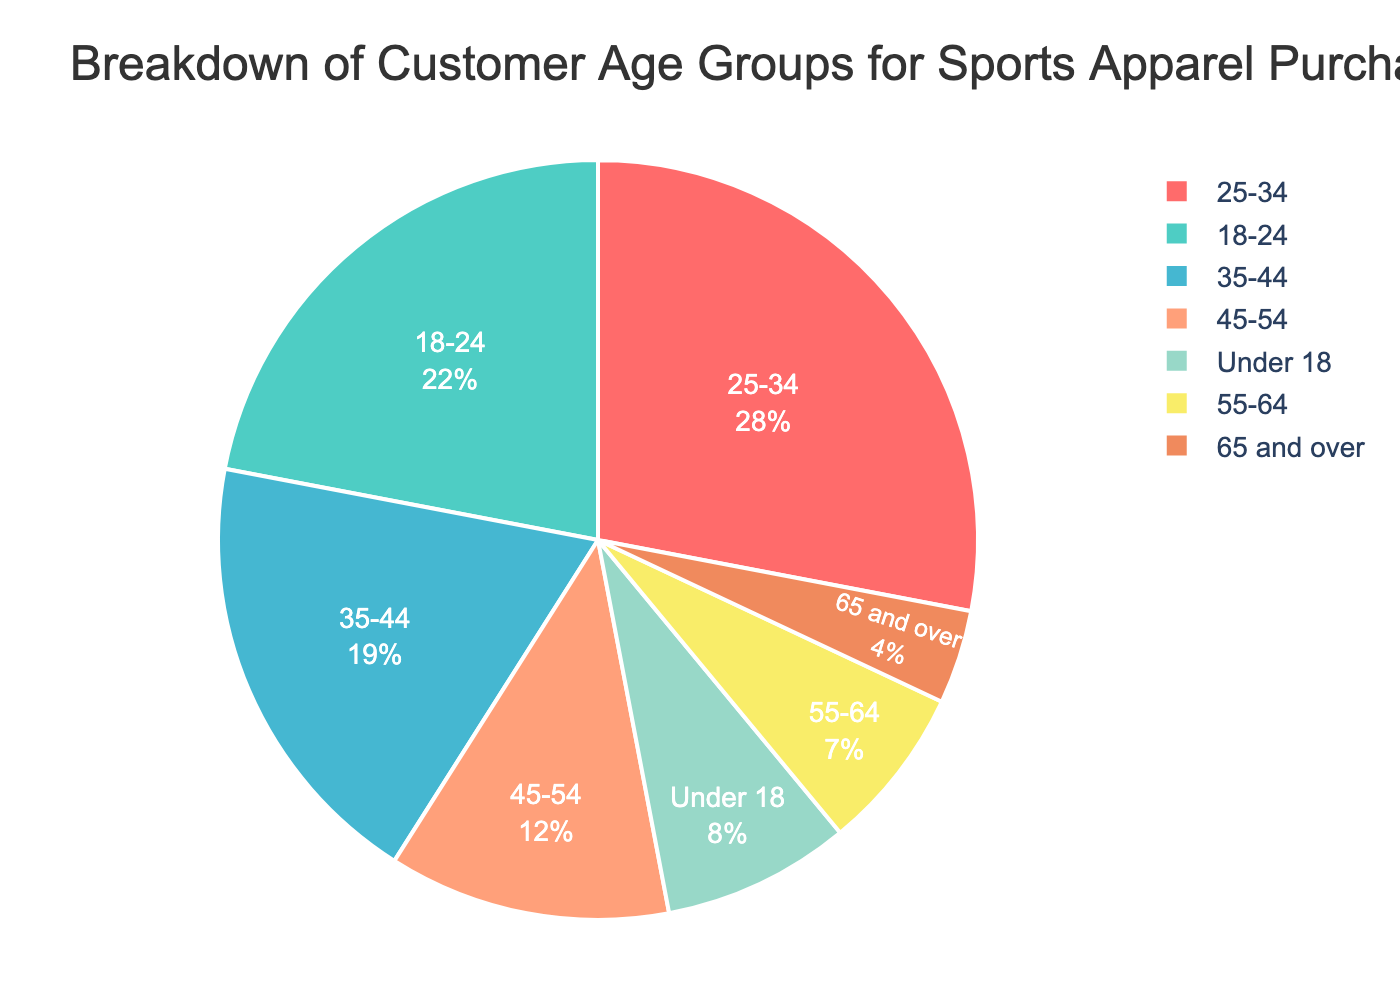What percentage of customers are aged 18-24? In the pie chart, look for the segment labeled "18-24" and read off the corresponding percentage.
Answer: 22% Which age group has the smallest percentage of customers? Look for the smallest segment in the pie chart and identify the label of that segment.
Answer: 65 and over What is the total percentage of customers aged 45 and above? Sum up the percentages of the age groups "45-54", "55-64", and "65 and over". 12% + 7% + 4% = 23%
Answer: 23% Which age group has a higher percentage of customers, Under 18 or 55-64? Compare the percentages associated with the age groups "Under 18" and "55-64". 8% (Under 18) vs 7% (55-64)
Answer: Under 18 What is the combined percentage of customers aged under 18 and over 65? Sum up the percentages of the age groups "Under 18" and "65 and over". 8% + 4% = 12%
Answer: 12% How does the percentage of customers aged 35-44 compare to those aged 35 and younger? Sum the percentages of the groups under 35: 8% (Under 18) + 22% (18-24) + 28% (25-34) = 58%. Compare this with the percentage for 35-44, which is 19%. 19% < 58%
Answer: 35-44 has a lower percentage What is the difference in the percentage of customers between the age groups 25-34 and 35-44? Subtract the percentage of the "35-44" age group from the "25-34" age group. 28% - 19% = 9%
Answer: 9% Which age group occupies the orange segment of the pie chart? Identify the color associated with the "orange" segment in the pie chart and find the corresponding age group label.
Answer: 35-44 What is the percentage of customers in the age group that is represented by the color green? Find the green segment in the pie chart and read off the corresponding percentage.
Answer: 18-24 has 22% 